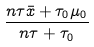Convert formula to latex. <formula><loc_0><loc_0><loc_500><loc_500>\frac { n \tau { \bar { x } } + \tau _ { 0 } \mu _ { 0 } } { n \tau + \tau _ { 0 } }</formula> 